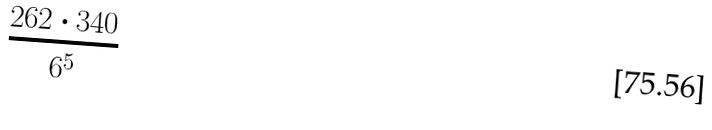Convert formula to latex. <formula><loc_0><loc_0><loc_500><loc_500>\frac { 2 6 2 \cdot 3 4 0 } { 6 ^ { 5 } }</formula> 